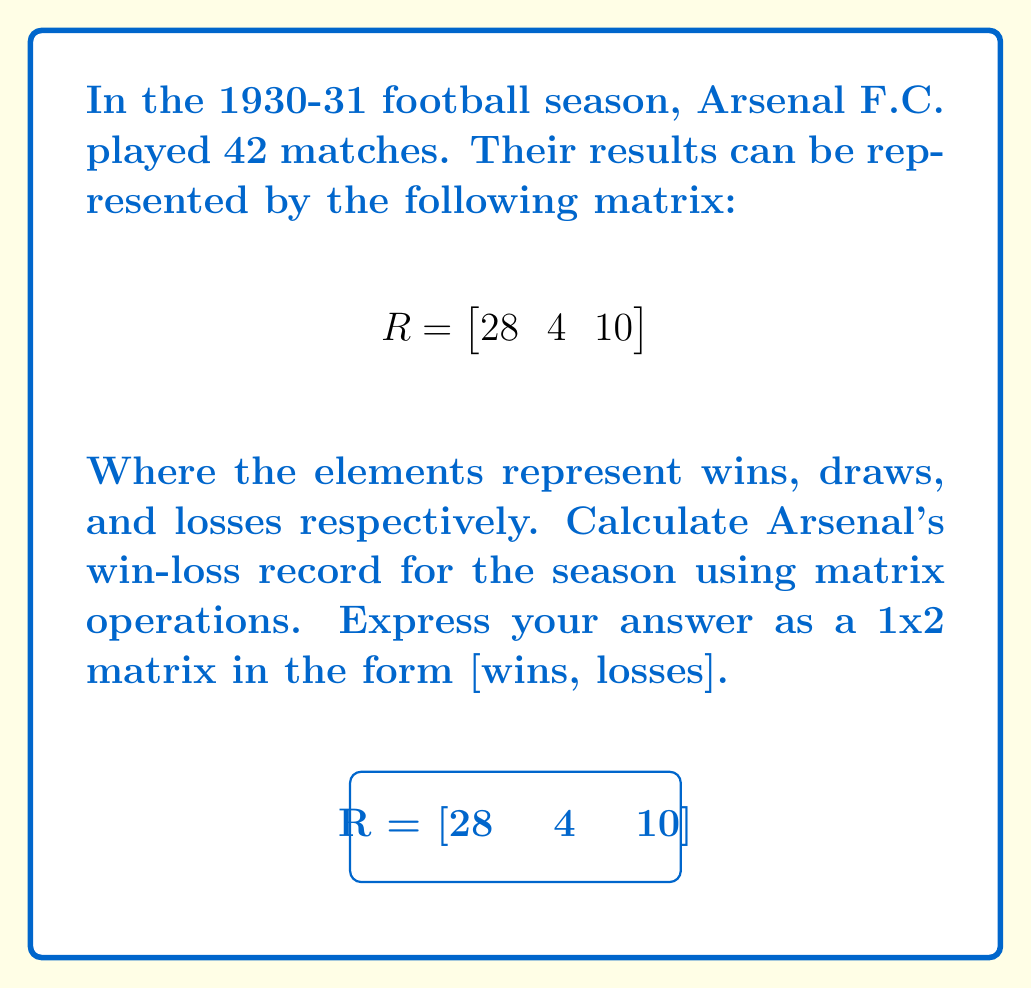Provide a solution to this math problem. To solve this problem, we need to follow these steps:

1) First, we need to understand that the win-loss record doesn't include draws. So we'll need to extract just the wins and losses from our matrix.

2) We can do this by using a transformation matrix. Let's call this matrix T:

   $$T = \begin{bmatrix}
   1 & 0 & 0 \\
   0 & 0 & 1
   \end{bmatrix}$$

3) Multiplying R by T will give us the win-loss record:

   $$RT = \begin{bmatrix}
   28 & 4 & 10
   \end{bmatrix} \begin{bmatrix}
   1 & 0 & 0 \\
   0 & 0 & 1
   \end{bmatrix}$$

4) Performing the matrix multiplication:

   $$RT = \begin{bmatrix}
   28 \cdot 1 + 4 \cdot 0 + 10 \cdot 0 & 28 \cdot 0 + 4 \cdot 0 + 10 \cdot 1
   \end{bmatrix}$$

5) Simplifying:

   $$RT = \begin{bmatrix}
   28 & 10
   \end{bmatrix}$$

Therefore, Arsenal's win-loss record for the 1930-31 season was 28 wins and 10 losses.
Answer: $\begin{bmatrix}
28 & 10
\end{bmatrix}$ 